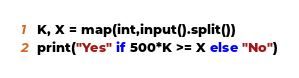Convert code to text. <code><loc_0><loc_0><loc_500><loc_500><_Python_>K, X = map(int,input().split())
print("Yes" if 500*K >= X else "No")</code> 